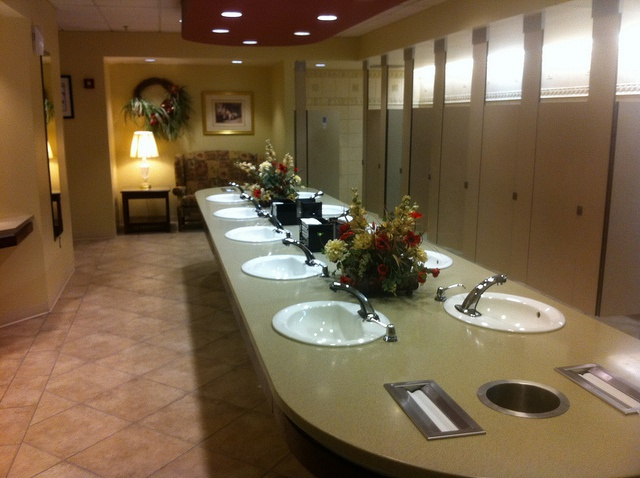Describe the objects in this image and their specific colors. I can see potted plant in brown, black, olive, maroon, and gray tones, sink in brown, lightgray, darkgray, and lightblue tones, sink in brown, lightgray, darkgray, and tan tones, couch in brown, black, maroon, and olive tones, and potted plant in brown, black, olive, and gray tones in this image. 